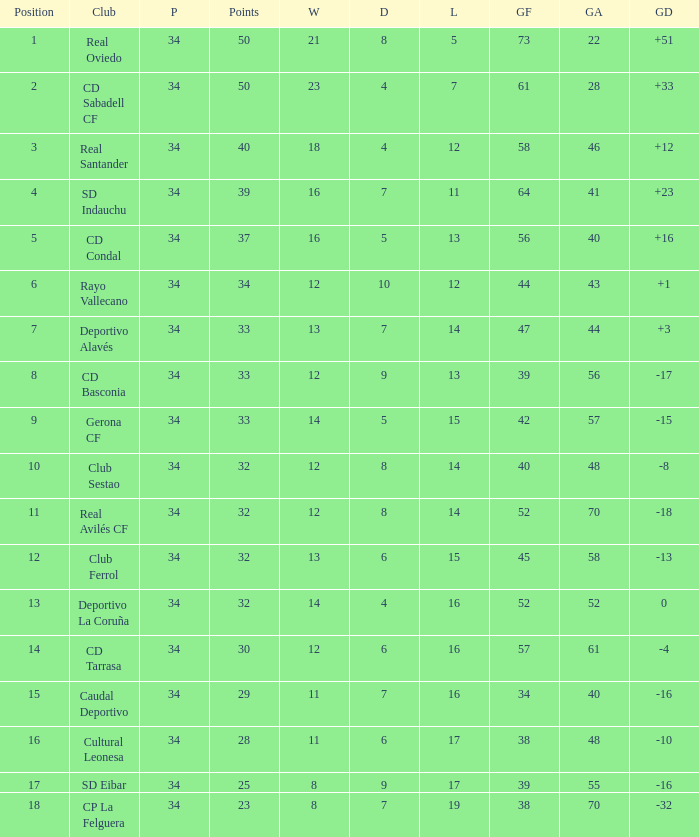Which Played has Draws smaller than 7, and Goals for smaller than 61, and Goals against smaller than 48, and a Position of 5? 34.0. 